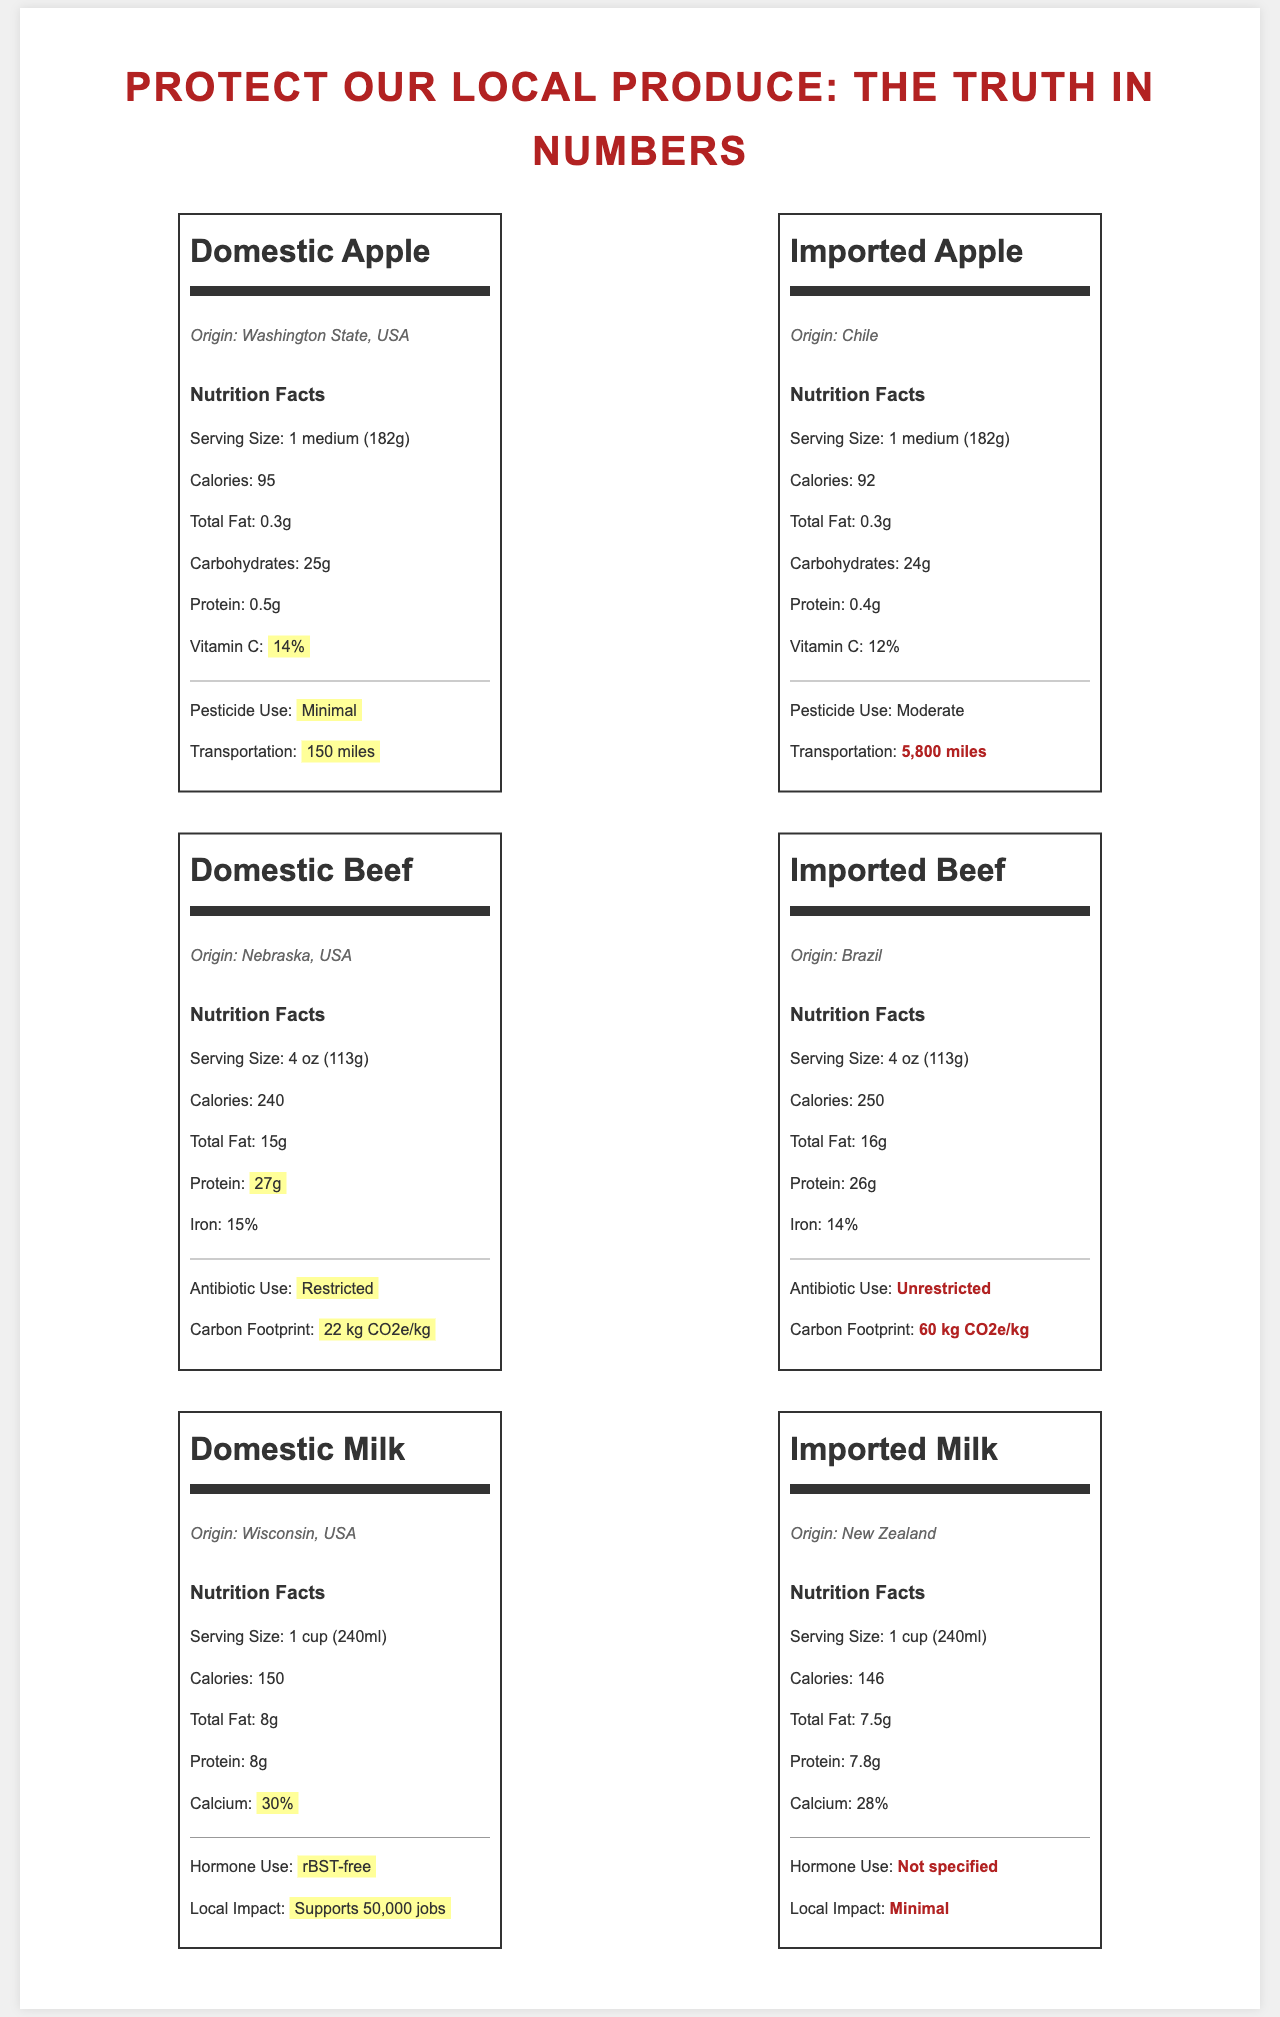what is the serving size of the domestic apple? The serving size for the domestic apple is listed as "1 medium (182g)" on the document.
Answer: 1 medium (182g) which apple has more vitamin C? The domestic apple has 14% vitamin C, while the imported apple has 12% vitamin C.
Answer: Domestic Apple what is the origin of the imported beef? According to the document, the imported beef is from Brazil.
Answer: Brazil how much calcium is in domestic milk? The nutrition label for domestic milk shows that it contains 30% calcium.
Answer: 30% which product has a higher carbon footprint: domestic beef or imported beef? The carbon footprint of imported beef is 60 kg CO2e/kg, whereas domestic beef has a carbon footprint of 22 kg CO2e/kg.
Answer: Imported Beef how far is the transportation distance for the imported apple? A. 150 miles B. 1,000 miles C. 5,800 miles D. 10,000 miles According to the document, the transportation distance for the imported apple is 5,800 miles.
Answer: C. 5,800 miles which of the following uses antibiotics unrestrictedly? A. Domestic Beef B. Imported Beef C. Domestic Milk D. Imported Milk The imported beef is the product that uses antibiotics without restriction, as stated in the document.
Answer: B. Imported Beef is the domestic milk rBST-free? The label for domestic milk highlights that it is "rBST-free".
Answer: Yes can you determine the cost of the products based on the document? The document provides nutritional and origin information but does not include pricing details.
Answer: Not enough information summarize the main idea of the document. The main idea of the document is to provide a comparative analysis of the nutritional facts, origins, and additional factors such as pesticide use, transportation distances, antibiotic use policies, carbon footprint, and economic impact on local industries for domestic versus imported produce. Factors that might favor domestically produced products are highlighted, likely to advocate for supporting local industries.
Answer: The document compares the nutritional facts, origin, and other attributes of domestic and imported produce, including apples, beef, and milk. It emphasizes the nutritional content, pesticide use, transportation distance, antibiotic use, carbon footprint, and local economic impact of domestic products compared to imported products. 